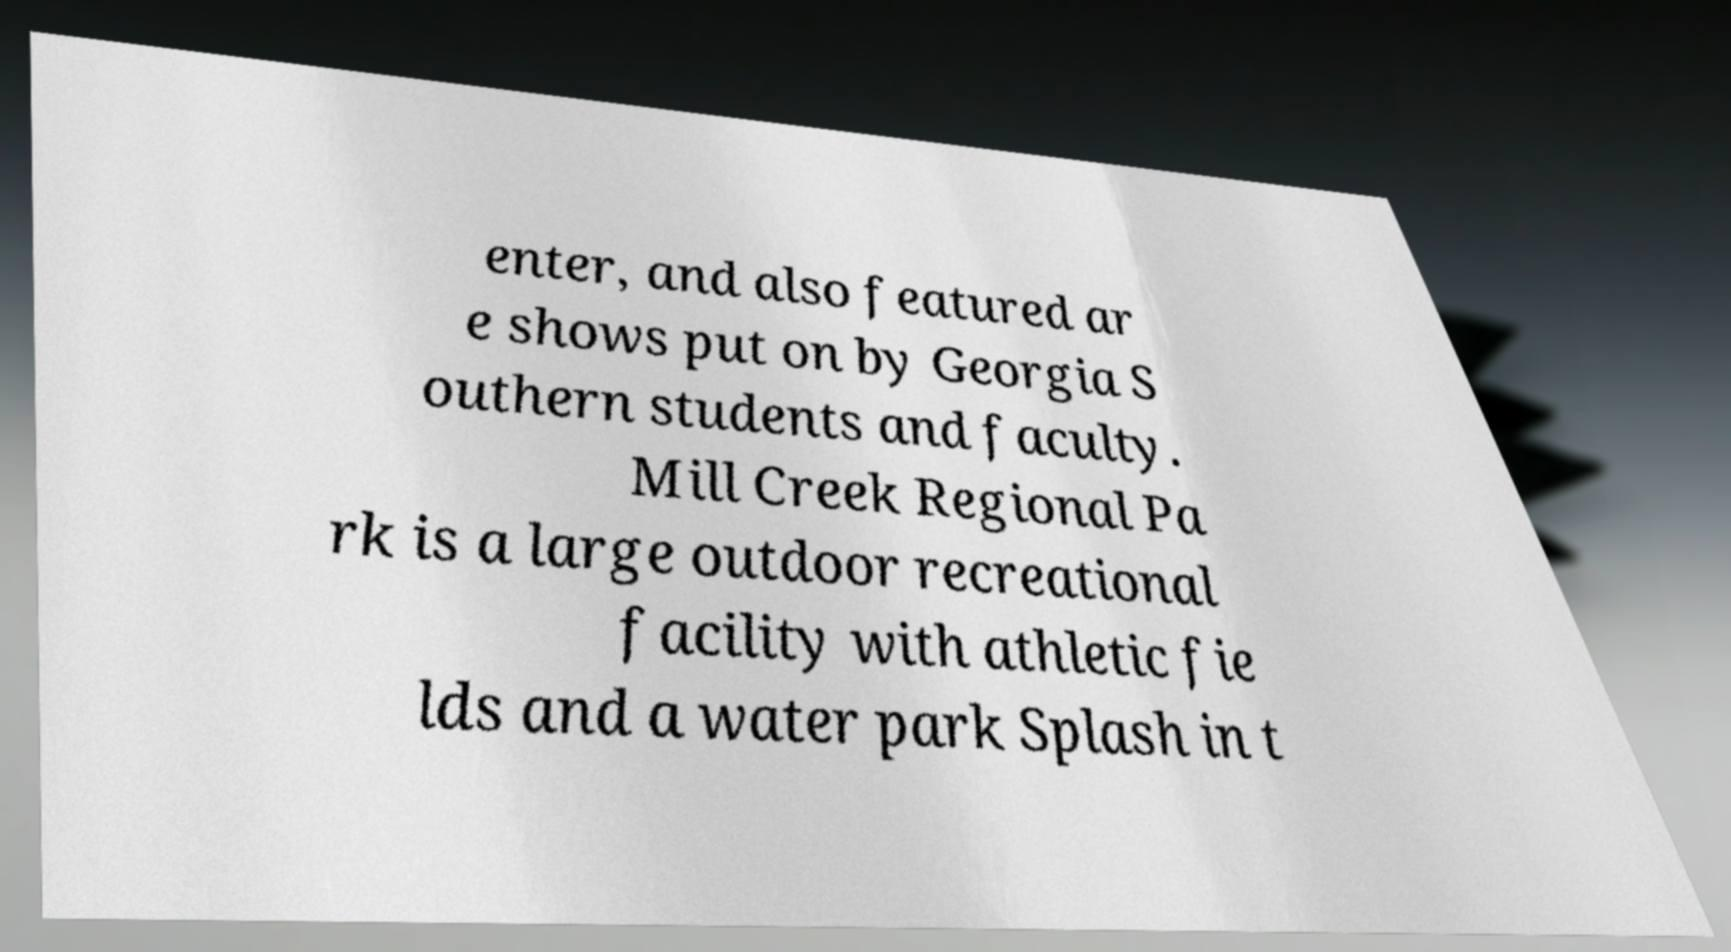There's text embedded in this image that I need extracted. Can you transcribe it verbatim? enter, and also featured ar e shows put on by Georgia S outhern students and faculty. Mill Creek Regional Pa rk is a large outdoor recreational facility with athletic fie lds and a water park Splash in t 